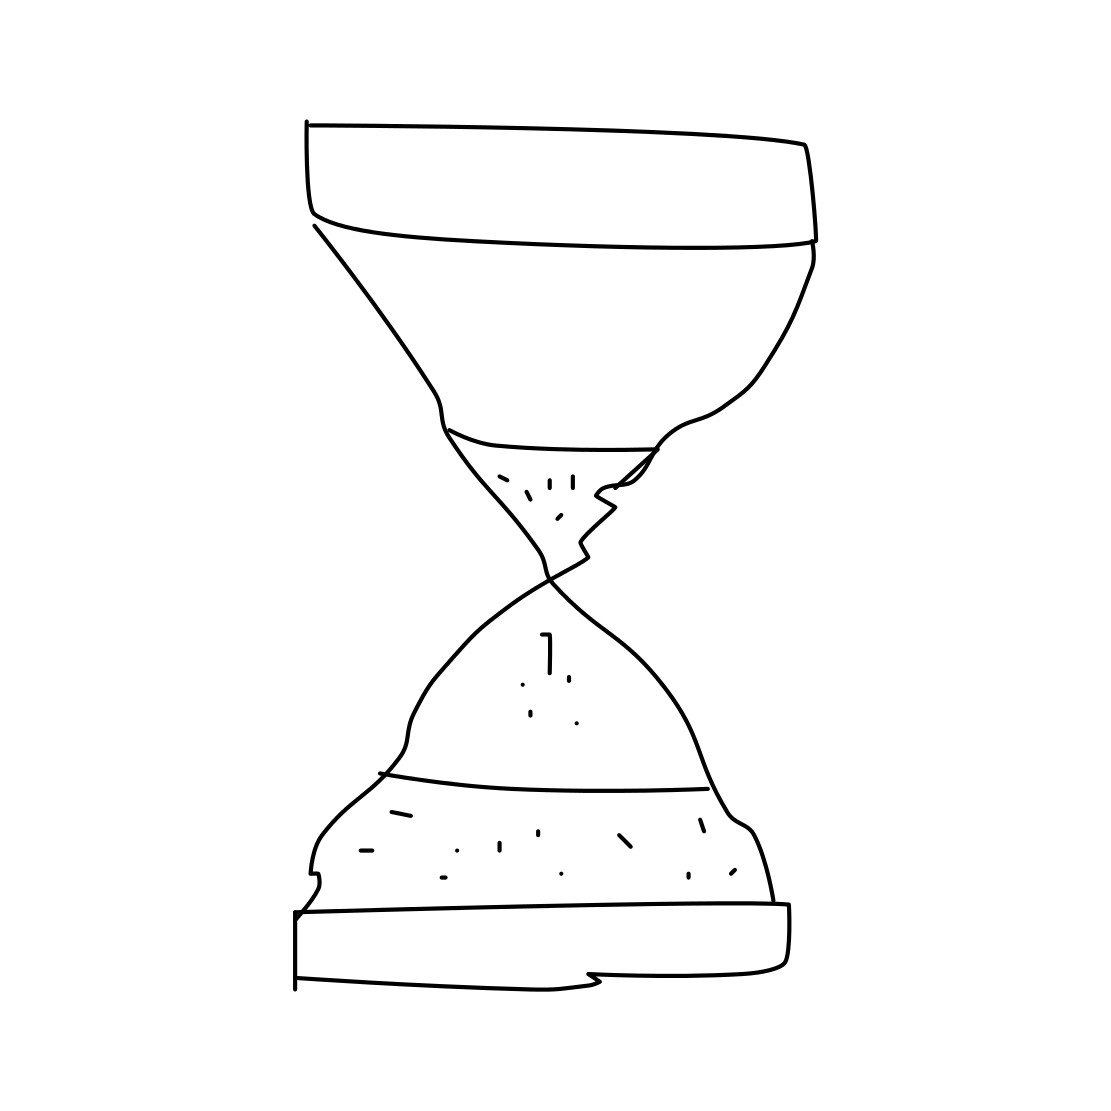Is this a hourglass in the image? Yes 